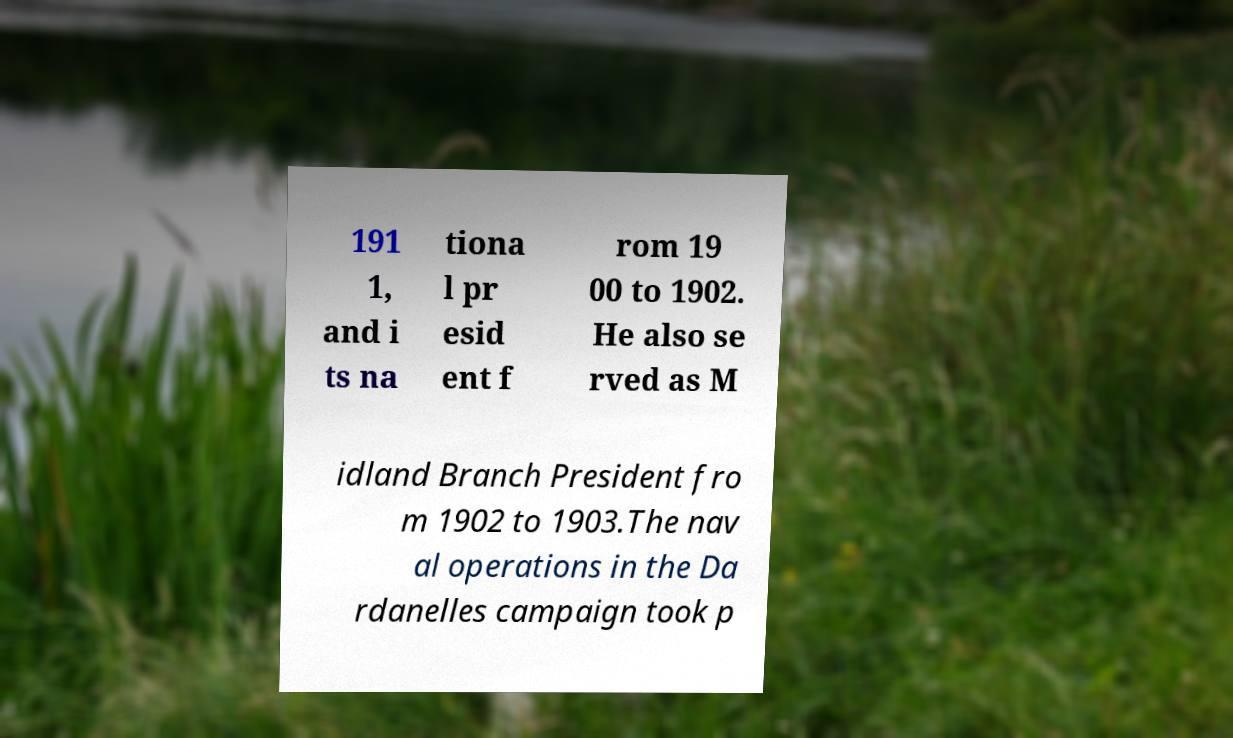What messages or text are displayed in this image? I need them in a readable, typed format. 191 1, and i ts na tiona l pr esid ent f rom 19 00 to 1902. He also se rved as M idland Branch President fro m 1902 to 1903.The nav al operations in the Da rdanelles campaign took p 